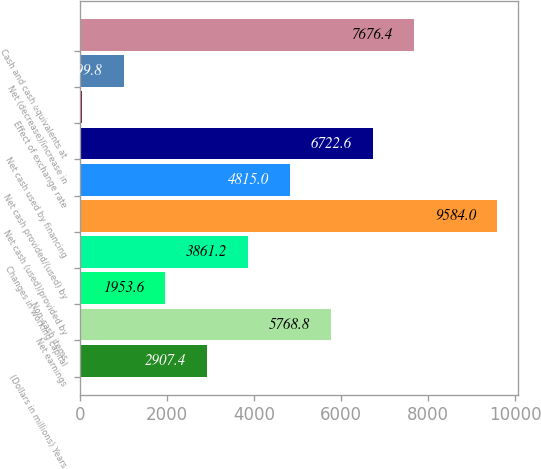Convert chart. <chart><loc_0><loc_0><loc_500><loc_500><bar_chart><fcel>(Dollars in millions) Years<fcel>Net earnings<fcel>Non-cash items<fcel>Changes in working capital<fcel>Net cash (used)/provided by<fcel>Net cash provided/(used) by<fcel>Net cash used by financing<fcel>Effect of exchange rate<fcel>Net (decrease)/increase in<fcel>Cash and cash equivalents at<nl><fcel>2907.4<fcel>5768.8<fcel>1953.6<fcel>3861.2<fcel>9584<fcel>4815<fcel>6722.6<fcel>46<fcel>999.8<fcel>7676.4<nl></chart> 